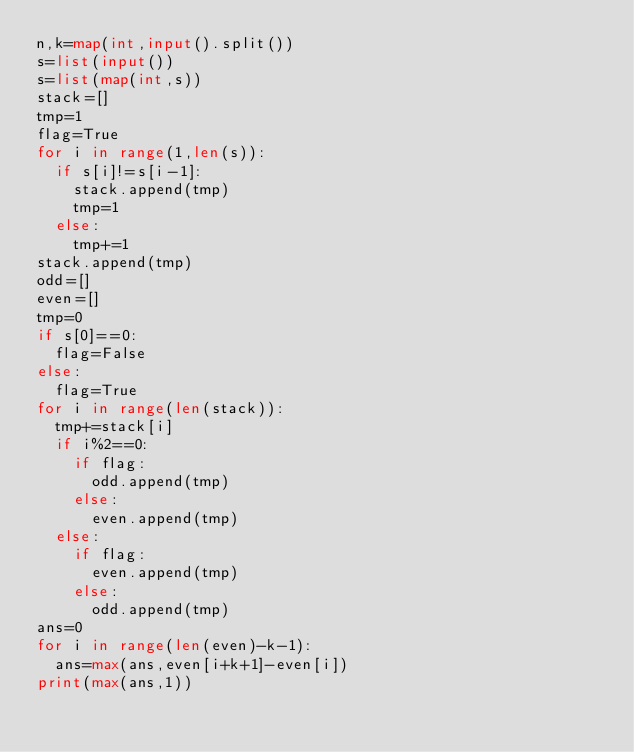Convert code to text. <code><loc_0><loc_0><loc_500><loc_500><_Python_>n,k=map(int,input().split())
s=list(input())
s=list(map(int,s))
stack=[]
tmp=1
flag=True
for i in range(1,len(s)):
  if s[i]!=s[i-1]:
    stack.append(tmp)
    tmp=1
  else:
    tmp+=1
stack.append(tmp)
odd=[]
even=[]
tmp=0
if s[0]==0:
  flag=False
else:
  flag=True
for i in range(len(stack)):
  tmp+=stack[i]
  if i%2==0:
    if flag:
      odd.append(tmp)
    else:
      even.append(tmp)
  else:
    if flag:
      even.append(tmp)
    else:
      odd.append(tmp)
ans=0
for i in range(len(even)-k-1):
  ans=max(ans,even[i+k+1]-even[i])
print(max(ans,1))
    </code> 